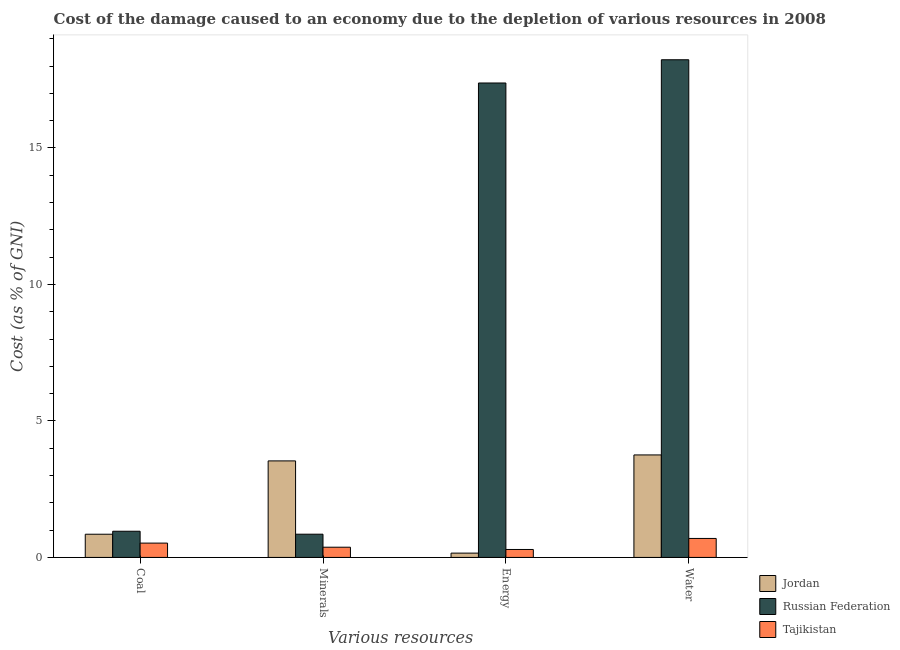How many groups of bars are there?
Provide a succinct answer. 4. Are the number of bars per tick equal to the number of legend labels?
Provide a succinct answer. Yes. Are the number of bars on each tick of the X-axis equal?
Keep it short and to the point. Yes. How many bars are there on the 2nd tick from the left?
Offer a very short reply. 3. What is the label of the 3rd group of bars from the left?
Keep it short and to the point. Energy. What is the cost of damage due to depletion of water in Jordan?
Make the answer very short. 3.75. Across all countries, what is the maximum cost of damage due to depletion of energy?
Offer a very short reply. 17.38. Across all countries, what is the minimum cost of damage due to depletion of energy?
Provide a succinct answer. 0.16. In which country was the cost of damage due to depletion of coal maximum?
Provide a succinct answer. Russian Federation. In which country was the cost of damage due to depletion of minerals minimum?
Give a very brief answer. Tajikistan. What is the total cost of damage due to depletion of energy in the graph?
Your answer should be very brief. 17.83. What is the difference between the cost of damage due to depletion of water in Russian Federation and that in Jordan?
Make the answer very short. 14.48. What is the difference between the cost of damage due to depletion of coal in Tajikistan and the cost of damage due to depletion of minerals in Russian Federation?
Your answer should be compact. -0.33. What is the average cost of damage due to depletion of energy per country?
Offer a terse response. 5.94. What is the difference between the cost of damage due to depletion of energy and cost of damage due to depletion of minerals in Tajikistan?
Offer a very short reply. -0.08. What is the ratio of the cost of damage due to depletion of minerals in Jordan to that in Russian Federation?
Keep it short and to the point. 4.16. What is the difference between the highest and the second highest cost of damage due to depletion of coal?
Your response must be concise. 0.11. What is the difference between the highest and the lowest cost of damage due to depletion of coal?
Provide a short and direct response. 0.43. In how many countries, is the cost of damage due to depletion of coal greater than the average cost of damage due to depletion of coal taken over all countries?
Your answer should be very brief. 2. What does the 3rd bar from the left in Energy represents?
Offer a very short reply. Tajikistan. What does the 3rd bar from the right in Energy represents?
Make the answer very short. Jordan. Is it the case that in every country, the sum of the cost of damage due to depletion of coal and cost of damage due to depletion of minerals is greater than the cost of damage due to depletion of energy?
Your answer should be very brief. No. Are all the bars in the graph horizontal?
Ensure brevity in your answer.  No. How many countries are there in the graph?
Your answer should be compact. 3. Where does the legend appear in the graph?
Give a very brief answer. Bottom right. What is the title of the graph?
Provide a succinct answer. Cost of the damage caused to an economy due to the depletion of various resources in 2008 . What is the label or title of the X-axis?
Provide a short and direct response. Various resources. What is the label or title of the Y-axis?
Your answer should be compact. Cost (as % of GNI). What is the Cost (as % of GNI) of Jordan in Coal?
Offer a terse response. 0.85. What is the Cost (as % of GNI) in Russian Federation in Coal?
Offer a terse response. 0.96. What is the Cost (as % of GNI) of Tajikistan in Coal?
Offer a very short reply. 0.52. What is the Cost (as % of GNI) of Jordan in Minerals?
Give a very brief answer. 3.54. What is the Cost (as % of GNI) of Russian Federation in Minerals?
Offer a very short reply. 0.85. What is the Cost (as % of GNI) of Tajikistan in Minerals?
Your response must be concise. 0.37. What is the Cost (as % of GNI) in Jordan in Energy?
Offer a terse response. 0.16. What is the Cost (as % of GNI) of Russian Federation in Energy?
Offer a terse response. 17.38. What is the Cost (as % of GNI) in Tajikistan in Energy?
Offer a terse response. 0.29. What is the Cost (as % of GNI) in Jordan in Water?
Your answer should be very brief. 3.75. What is the Cost (as % of GNI) in Russian Federation in Water?
Offer a very short reply. 18.23. What is the Cost (as % of GNI) of Tajikistan in Water?
Make the answer very short. 0.7. Across all Various resources, what is the maximum Cost (as % of GNI) of Jordan?
Give a very brief answer. 3.75. Across all Various resources, what is the maximum Cost (as % of GNI) of Russian Federation?
Keep it short and to the point. 18.23. Across all Various resources, what is the maximum Cost (as % of GNI) of Tajikistan?
Ensure brevity in your answer.  0.7. Across all Various resources, what is the minimum Cost (as % of GNI) of Jordan?
Your answer should be very brief. 0.16. Across all Various resources, what is the minimum Cost (as % of GNI) of Russian Federation?
Your response must be concise. 0.85. Across all Various resources, what is the minimum Cost (as % of GNI) in Tajikistan?
Make the answer very short. 0.29. What is the total Cost (as % of GNI) of Jordan in the graph?
Keep it short and to the point. 8.3. What is the total Cost (as % of GNI) in Russian Federation in the graph?
Offer a very short reply. 37.42. What is the total Cost (as % of GNI) of Tajikistan in the graph?
Your answer should be compact. 1.89. What is the difference between the Cost (as % of GNI) in Jordan in Coal and that in Minerals?
Offer a very short reply. -2.69. What is the difference between the Cost (as % of GNI) in Russian Federation in Coal and that in Minerals?
Give a very brief answer. 0.11. What is the difference between the Cost (as % of GNI) in Tajikistan in Coal and that in Minerals?
Your answer should be compact. 0.15. What is the difference between the Cost (as % of GNI) of Jordan in Coal and that in Energy?
Your response must be concise. 0.69. What is the difference between the Cost (as % of GNI) in Russian Federation in Coal and that in Energy?
Your response must be concise. -16.42. What is the difference between the Cost (as % of GNI) of Tajikistan in Coal and that in Energy?
Keep it short and to the point. 0.23. What is the difference between the Cost (as % of GNI) of Jordan in Coal and that in Water?
Offer a terse response. -2.9. What is the difference between the Cost (as % of GNI) in Russian Federation in Coal and that in Water?
Ensure brevity in your answer.  -17.27. What is the difference between the Cost (as % of GNI) in Tajikistan in Coal and that in Water?
Provide a short and direct response. -0.17. What is the difference between the Cost (as % of GNI) of Jordan in Minerals and that in Energy?
Your response must be concise. 3.38. What is the difference between the Cost (as % of GNI) of Russian Federation in Minerals and that in Energy?
Offer a terse response. -16.53. What is the difference between the Cost (as % of GNI) of Tajikistan in Minerals and that in Energy?
Provide a succinct answer. 0.08. What is the difference between the Cost (as % of GNI) of Jordan in Minerals and that in Water?
Offer a very short reply. -0.22. What is the difference between the Cost (as % of GNI) in Russian Federation in Minerals and that in Water?
Provide a short and direct response. -17.38. What is the difference between the Cost (as % of GNI) of Tajikistan in Minerals and that in Water?
Give a very brief answer. -0.32. What is the difference between the Cost (as % of GNI) of Jordan in Energy and that in Water?
Make the answer very short. -3.6. What is the difference between the Cost (as % of GNI) of Russian Federation in Energy and that in Water?
Make the answer very short. -0.85. What is the difference between the Cost (as % of GNI) in Tajikistan in Energy and that in Water?
Provide a succinct answer. -0.4. What is the difference between the Cost (as % of GNI) of Jordan in Coal and the Cost (as % of GNI) of Russian Federation in Minerals?
Offer a very short reply. -0. What is the difference between the Cost (as % of GNI) in Jordan in Coal and the Cost (as % of GNI) in Tajikistan in Minerals?
Your answer should be very brief. 0.48. What is the difference between the Cost (as % of GNI) in Russian Federation in Coal and the Cost (as % of GNI) in Tajikistan in Minerals?
Offer a very short reply. 0.58. What is the difference between the Cost (as % of GNI) in Jordan in Coal and the Cost (as % of GNI) in Russian Federation in Energy?
Keep it short and to the point. -16.53. What is the difference between the Cost (as % of GNI) of Jordan in Coal and the Cost (as % of GNI) of Tajikistan in Energy?
Provide a succinct answer. 0.56. What is the difference between the Cost (as % of GNI) of Russian Federation in Coal and the Cost (as % of GNI) of Tajikistan in Energy?
Provide a short and direct response. 0.67. What is the difference between the Cost (as % of GNI) of Jordan in Coal and the Cost (as % of GNI) of Russian Federation in Water?
Your answer should be compact. -17.38. What is the difference between the Cost (as % of GNI) of Jordan in Coal and the Cost (as % of GNI) of Tajikistan in Water?
Give a very brief answer. 0.15. What is the difference between the Cost (as % of GNI) of Russian Federation in Coal and the Cost (as % of GNI) of Tajikistan in Water?
Provide a short and direct response. 0.26. What is the difference between the Cost (as % of GNI) in Jordan in Minerals and the Cost (as % of GNI) in Russian Federation in Energy?
Give a very brief answer. -13.84. What is the difference between the Cost (as % of GNI) of Jordan in Minerals and the Cost (as % of GNI) of Tajikistan in Energy?
Offer a very short reply. 3.24. What is the difference between the Cost (as % of GNI) in Russian Federation in Minerals and the Cost (as % of GNI) in Tajikistan in Energy?
Provide a short and direct response. 0.56. What is the difference between the Cost (as % of GNI) in Jordan in Minerals and the Cost (as % of GNI) in Russian Federation in Water?
Offer a terse response. -14.7. What is the difference between the Cost (as % of GNI) of Jordan in Minerals and the Cost (as % of GNI) of Tajikistan in Water?
Your answer should be very brief. 2.84. What is the difference between the Cost (as % of GNI) of Russian Federation in Minerals and the Cost (as % of GNI) of Tajikistan in Water?
Your response must be concise. 0.16. What is the difference between the Cost (as % of GNI) of Jordan in Energy and the Cost (as % of GNI) of Russian Federation in Water?
Provide a short and direct response. -18.07. What is the difference between the Cost (as % of GNI) in Jordan in Energy and the Cost (as % of GNI) in Tajikistan in Water?
Provide a short and direct response. -0.54. What is the difference between the Cost (as % of GNI) in Russian Federation in Energy and the Cost (as % of GNI) in Tajikistan in Water?
Provide a succinct answer. 16.69. What is the average Cost (as % of GNI) in Jordan per Various resources?
Give a very brief answer. 2.07. What is the average Cost (as % of GNI) of Russian Federation per Various resources?
Provide a short and direct response. 9.36. What is the average Cost (as % of GNI) of Tajikistan per Various resources?
Your answer should be compact. 0.47. What is the difference between the Cost (as % of GNI) in Jordan and Cost (as % of GNI) in Russian Federation in Coal?
Keep it short and to the point. -0.11. What is the difference between the Cost (as % of GNI) of Jordan and Cost (as % of GNI) of Tajikistan in Coal?
Your response must be concise. 0.33. What is the difference between the Cost (as % of GNI) of Russian Federation and Cost (as % of GNI) of Tajikistan in Coal?
Provide a short and direct response. 0.43. What is the difference between the Cost (as % of GNI) of Jordan and Cost (as % of GNI) of Russian Federation in Minerals?
Keep it short and to the point. 2.69. What is the difference between the Cost (as % of GNI) of Jordan and Cost (as % of GNI) of Tajikistan in Minerals?
Your answer should be very brief. 3.16. What is the difference between the Cost (as % of GNI) of Russian Federation and Cost (as % of GNI) of Tajikistan in Minerals?
Your answer should be compact. 0.48. What is the difference between the Cost (as % of GNI) in Jordan and Cost (as % of GNI) in Russian Federation in Energy?
Your answer should be compact. -17.22. What is the difference between the Cost (as % of GNI) in Jordan and Cost (as % of GNI) in Tajikistan in Energy?
Your answer should be very brief. -0.13. What is the difference between the Cost (as % of GNI) in Russian Federation and Cost (as % of GNI) in Tajikistan in Energy?
Provide a succinct answer. 17.09. What is the difference between the Cost (as % of GNI) in Jordan and Cost (as % of GNI) in Russian Federation in Water?
Offer a terse response. -14.48. What is the difference between the Cost (as % of GNI) of Jordan and Cost (as % of GNI) of Tajikistan in Water?
Offer a very short reply. 3.06. What is the difference between the Cost (as % of GNI) in Russian Federation and Cost (as % of GNI) in Tajikistan in Water?
Offer a very short reply. 17.54. What is the ratio of the Cost (as % of GNI) in Jordan in Coal to that in Minerals?
Keep it short and to the point. 0.24. What is the ratio of the Cost (as % of GNI) in Russian Federation in Coal to that in Minerals?
Your response must be concise. 1.13. What is the ratio of the Cost (as % of GNI) in Tajikistan in Coal to that in Minerals?
Give a very brief answer. 1.4. What is the ratio of the Cost (as % of GNI) in Jordan in Coal to that in Energy?
Ensure brevity in your answer.  5.38. What is the ratio of the Cost (as % of GNI) in Russian Federation in Coal to that in Energy?
Make the answer very short. 0.06. What is the ratio of the Cost (as % of GNI) of Tajikistan in Coal to that in Energy?
Offer a very short reply. 1.8. What is the ratio of the Cost (as % of GNI) in Jordan in Coal to that in Water?
Keep it short and to the point. 0.23. What is the ratio of the Cost (as % of GNI) in Russian Federation in Coal to that in Water?
Your response must be concise. 0.05. What is the ratio of the Cost (as % of GNI) in Tajikistan in Coal to that in Water?
Your response must be concise. 0.75. What is the ratio of the Cost (as % of GNI) of Jordan in Minerals to that in Energy?
Provide a short and direct response. 22.36. What is the ratio of the Cost (as % of GNI) of Russian Federation in Minerals to that in Energy?
Your answer should be compact. 0.05. What is the ratio of the Cost (as % of GNI) of Tajikistan in Minerals to that in Energy?
Ensure brevity in your answer.  1.28. What is the ratio of the Cost (as % of GNI) of Jordan in Minerals to that in Water?
Your answer should be compact. 0.94. What is the ratio of the Cost (as % of GNI) in Russian Federation in Minerals to that in Water?
Your answer should be compact. 0.05. What is the ratio of the Cost (as % of GNI) in Tajikistan in Minerals to that in Water?
Provide a succinct answer. 0.54. What is the ratio of the Cost (as % of GNI) of Jordan in Energy to that in Water?
Ensure brevity in your answer.  0.04. What is the ratio of the Cost (as % of GNI) of Russian Federation in Energy to that in Water?
Provide a succinct answer. 0.95. What is the ratio of the Cost (as % of GNI) of Tajikistan in Energy to that in Water?
Your answer should be compact. 0.42. What is the difference between the highest and the second highest Cost (as % of GNI) in Jordan?
Your answer should be very brief. 0.22. What is the difference between the highest and the second highest Cost (as % of GNI) in Russian Federation?
Give a very brief answer. 0.85. What is the difference between the highest and the second highest Cost (as % of GNI) in Tajikistan?
Your answer should be very brief. 0.17. What is the difference between the highest and the lowest Cost (as % of GNI) in Jordan?
Give a very brief answer. 3.6. What is the difference between the highest and the lowest Cost (as % of GNI) in Russian Federation?
Ensure brevity in your answer.  17.38. What is the difference between the highest and the lowest Cost (as % of GNI) in Tajikistan?
Keep it short and to the point. 0.4. 